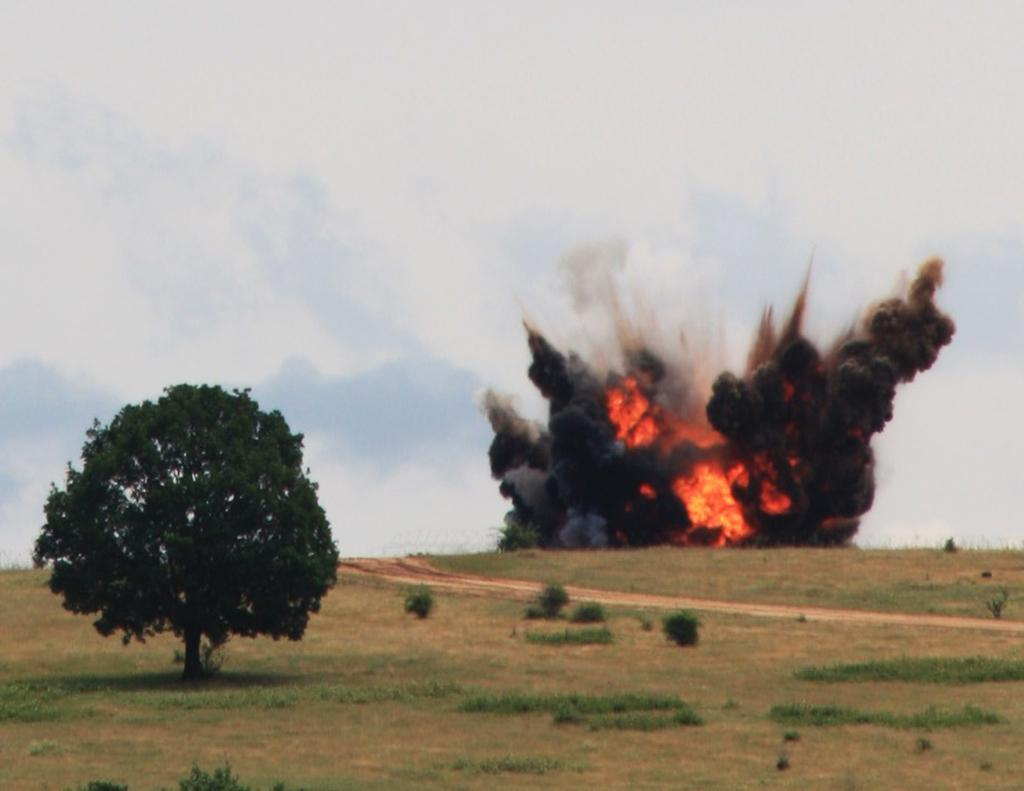What type of vegetation can be seen in the image? There is a tree, grass, and plants on the ground visible in the image. What is the source of the fire in the image? The source of the fire is not visible in the image. What is the result of the fire in the image? The result of the fire is visible smoke in the image. What is visible in the background of the image? There are clouds and the sky visible in the background of the image. What type of thread is being used to create the morning sky in the image? There is no thread present in the image, and the morning sky is not a part of the image. What type of carriage can be seen in the image? There is no carriage present in the image. 